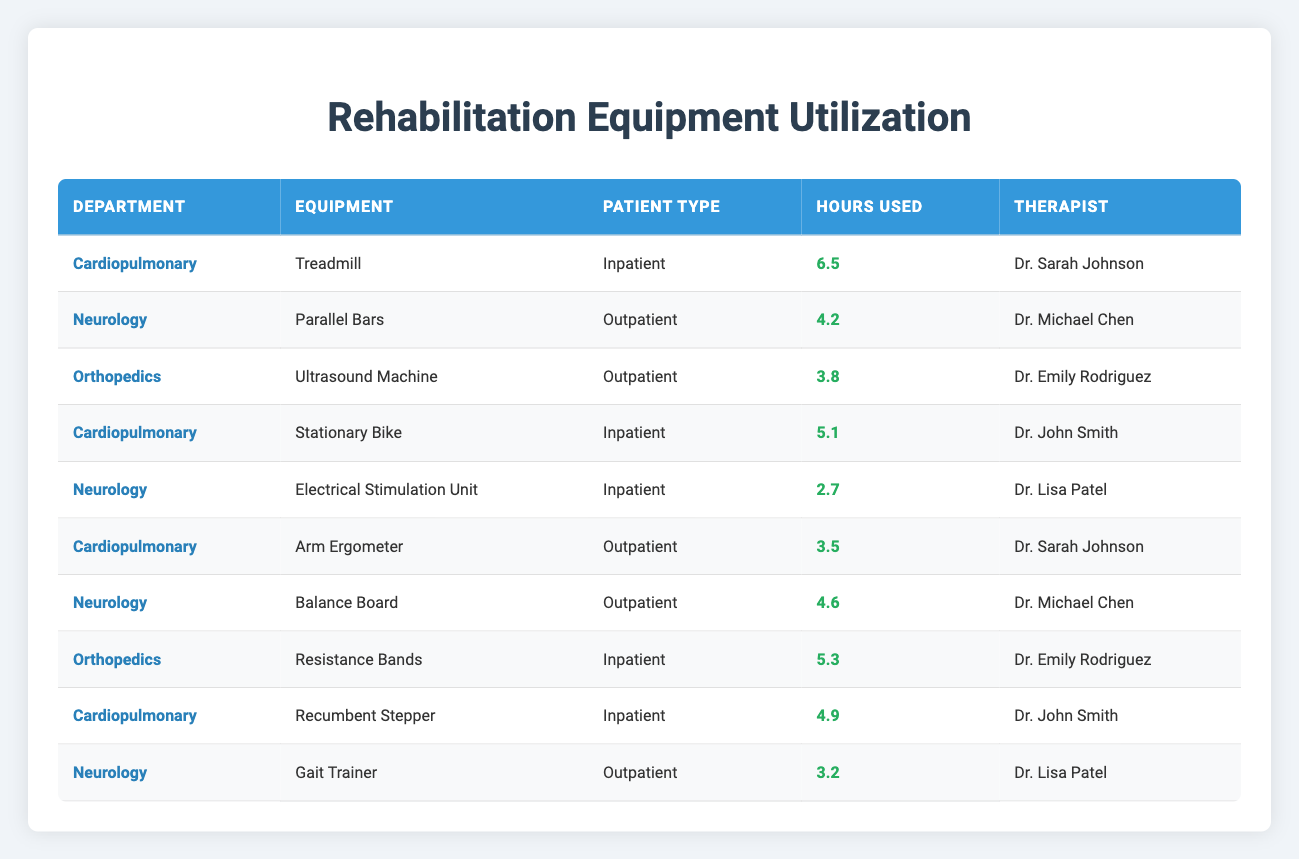What is the total hours used for the Treadmill in the Cardiopulmonary department? The table shows that the Treadmill was used for 6.5 hours in the Cardiopulmonary department. Since there is only one entry for this equipment, the total hours used is simply 6.5.
Answer: 6.5 Which equipment was used the least in terms of hours in the Neurology department? In the Neurology department, the equipment utilization hours are as follows: Parallel Bars (4.2 hours), Electrical Stimulation Unit (2.7 hours), Balance Board (4.6 hours), and Gait Trainer (3.2 hours). The least used is the Electrical Stimulation Unit at 2.7 hours.
Answer: Electrical Stimulation Unit What is the average utilization time for equipment in the Orthopedics department? The total hours used for the Orthopedics department's equipment are Ultrasound Machine (3.8 hours) and Resistance Bands (5.3 hours), summing up to 9.1 hours. There are 2 entries, so the average is 9.1 divided by 2, which equals 4.55 hours.
Answer: 4.55 Is the Arm Ergometer used exclusively for outpatient services? The table shows that the Arm Ergometer was used by Dr. Sarah Johnson for outpatient service only. There are no entries indicating it was used for inpatient services.
Answer: Yes Which therapist has the highest total equipment usage hours in the Cardiopulmonary department? In the Cardiopulmonary department, the equipment hours for each therapist are: Dr. Sarah Johnson (Treadmill - 6.5 hours, Arm Ergometer - 3.5 hours = 10 hours total), Dr. John Smith (Stationary Bike - 5.1 hours, Recumbent Stepper - 4.9 hours = 10 hours total). Both therapists have the same total usage of 10 hours, so they are tied.
Answer: Dr. Sarah Johnson and Dr. John Smith (10 hours each) What are the total hours used for all inpatient services combined? The hours for inpatient services are: Treadmill (6.5 hours), Stationary Bike (5.1 hours), Electrical Stimulation Unit (2.7 hours), Resistance Bands (5.3 hours), and Recumbent Stepper (4.9 hours). Adding these, we get 6.5 + 5.1 + 2.7 + 5.3 + 4.9 = 24.5 hours total for inpatient services.
Answer: 24.5 How many different types of equipment are used in the Neurology department? The table lists 4 different equipment items used in Neurology: Parallel Bars, Electrical Stimulation Unit, Balance Board, and Gait Trainer. Thus, there are 4 unique equipment types in the Neurology department.
Answer: 4 What is the total usage of the equipment in hours exclusively for outpatient services? In the outpatient category, the equipment hours are: Parallel Bars (4.2 hours), Ultrasound Machine (3.8 hours), Arm Ergometer (3.5 hours), Balance Board (4.6 hours), and Gait Trainer (3.2 hours). Adding these gives us 4.2 + 3.8 + 3.5 + 4.6 + 3.2 = 19.3 hours for outpatient services.
Answer: 19.3 Which department had the highest single equipment utilization hour and what was that equipment? The Treadmill in the Cardiopulmonary department was used for 6.5 hours, which is the highest single equipment utilization hour in the table.
Answer: Treadmill in Cardiopulmonary department (6.5 hours) 